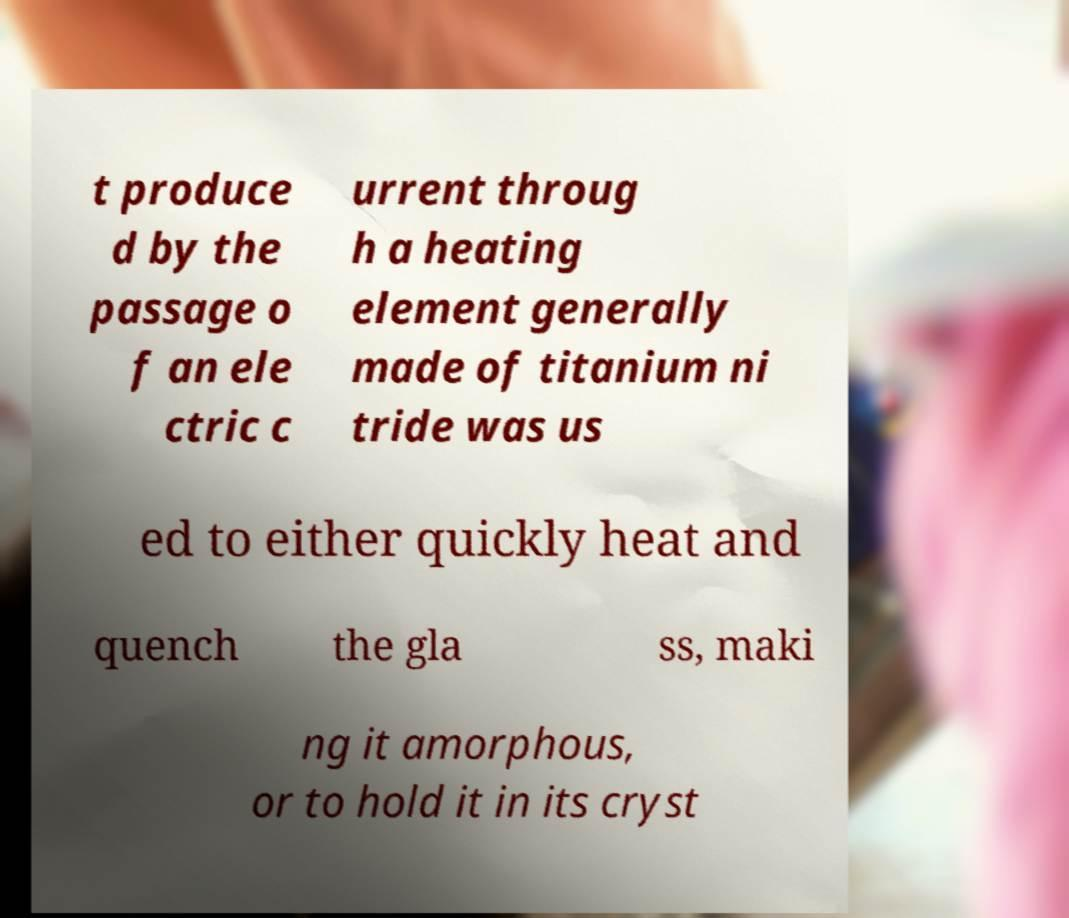There's text embedded in this image that I need extracted. Can you transcribe it verbatim? t produce d by the passage o f an ele ctric c urrent throug h a heating element generally made of titanium ni tride was us ed to either quickly heat and quench the gla ss, maki ng it amorphous, or to hold it in its cryst 